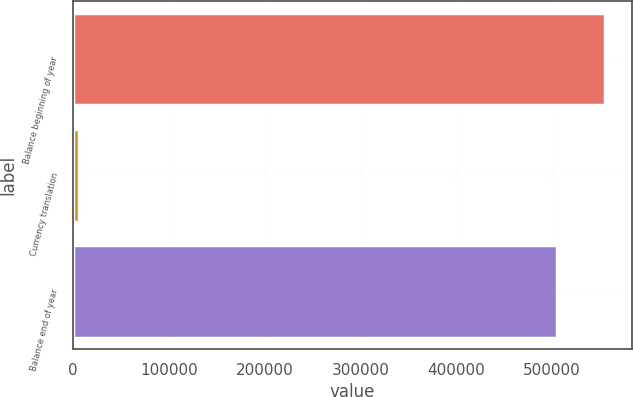Convert chart to OTSL. <chart><loc_0><loc_0><loc_500><loc_500><bar_chart><fcel>Balance beginning of year<fcel>Currency translation<fcel>Balance end of year<nl><fcel>555262<fcel>6110<fcel>504784<nl></chart> 